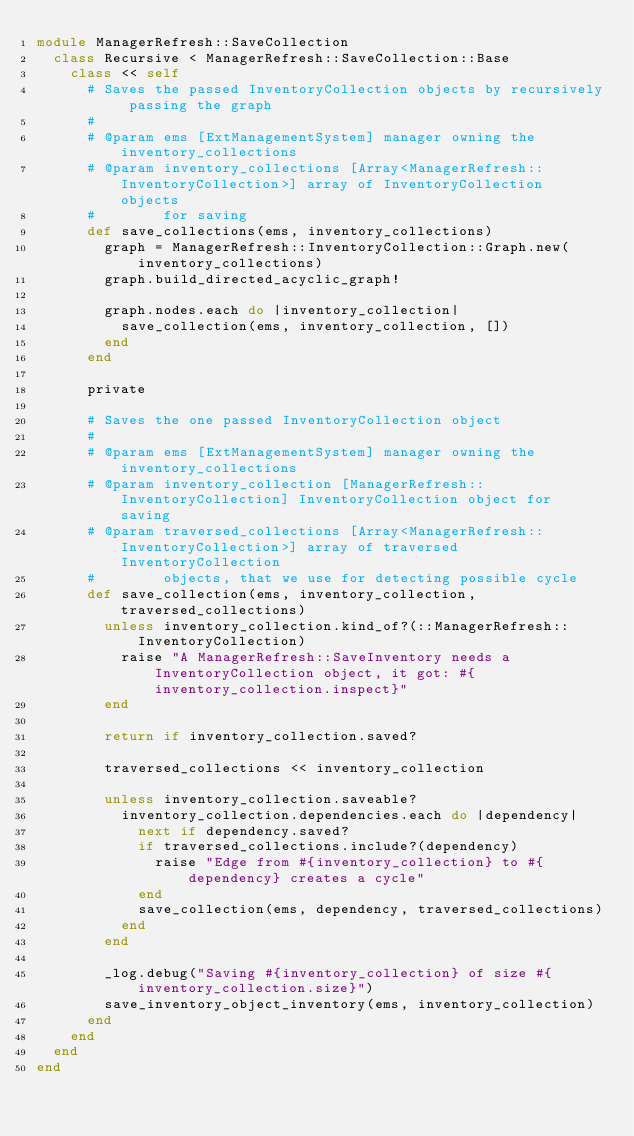<code> <loc_0><loc_0><loc_500><loc_500><_Ruby_>module ManagerRefresh::SaveCollection
  class Recursive < ManagerRefresh::SaveCollection::Base
    class << self
      # Saves the passed InventoryCollection objects by recursively passing the graph
      #
      # @param ems [ExtManagementSystem] manager owning the inventory_collections
      # @param inventory_collections [Array<ManagerRefresh::InventoryCollection>] array of InventoryCollection objects
      #        for saving
      def save_collections(ems, inventory_collections)
        graph = ManagerRefresh::InventoryCollection::Graph.new(inventory_collections)
        graph.build_directed_acyclic_graph!

        graph.nodes.each do |inventory_collection|
          save_collection(ems, inventory_collection, [])
        end
      end

      private

      # Saves the one passed InventoryCollection object
      #
      # @param ems [ExtManagementSystem] manager owning the inventory_collections
      # @param inventory_collection [ManagerRefresh::InventoryCollection] InventoryCollection object for saving
      # @param traversed_collections [Array<ManagerRefresh::InventoryCollection>] array of traversed InventoryCollection
      #        objects, that we use for detecting possible cycle
      def save_collection(ems, inventory_collection, traversed_collections)
        unless inventory_collection.kind_of?(::ManagerRefresh::InventoryCollection)
          raise "A ManagerRefresh::SaveInventory needs a InventoryCollection object, it got: #{inventory_collection.inspect}"
        end

        return if inventory_collection.saved?

        traversed_collections << inventory_collection

        unless inventory_collection.saveable?
          inventory_collection.dependencies.each do |dependency|
            next if dependency.saved?
            if traversed_collections.include?(dependency)
              raise "Edge from #{inventory_collection} to #{dependency} creates a cycle"
            end
            save_collection(ems, dependency, traversed_collections)
          end
        end

        _log.debug("Saving #{inventory_collection} of size #{inventory_collection.size}")
        save_inventory_object_inventory(ems, inventory_collection)
      end
    end
  end
end
</code> 